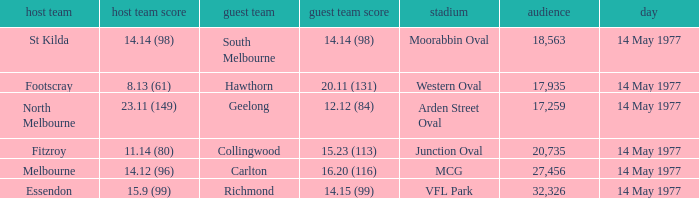I want to know the home team score of the away team of richmond that has a crowd more than 20,735 15.9 (99). 